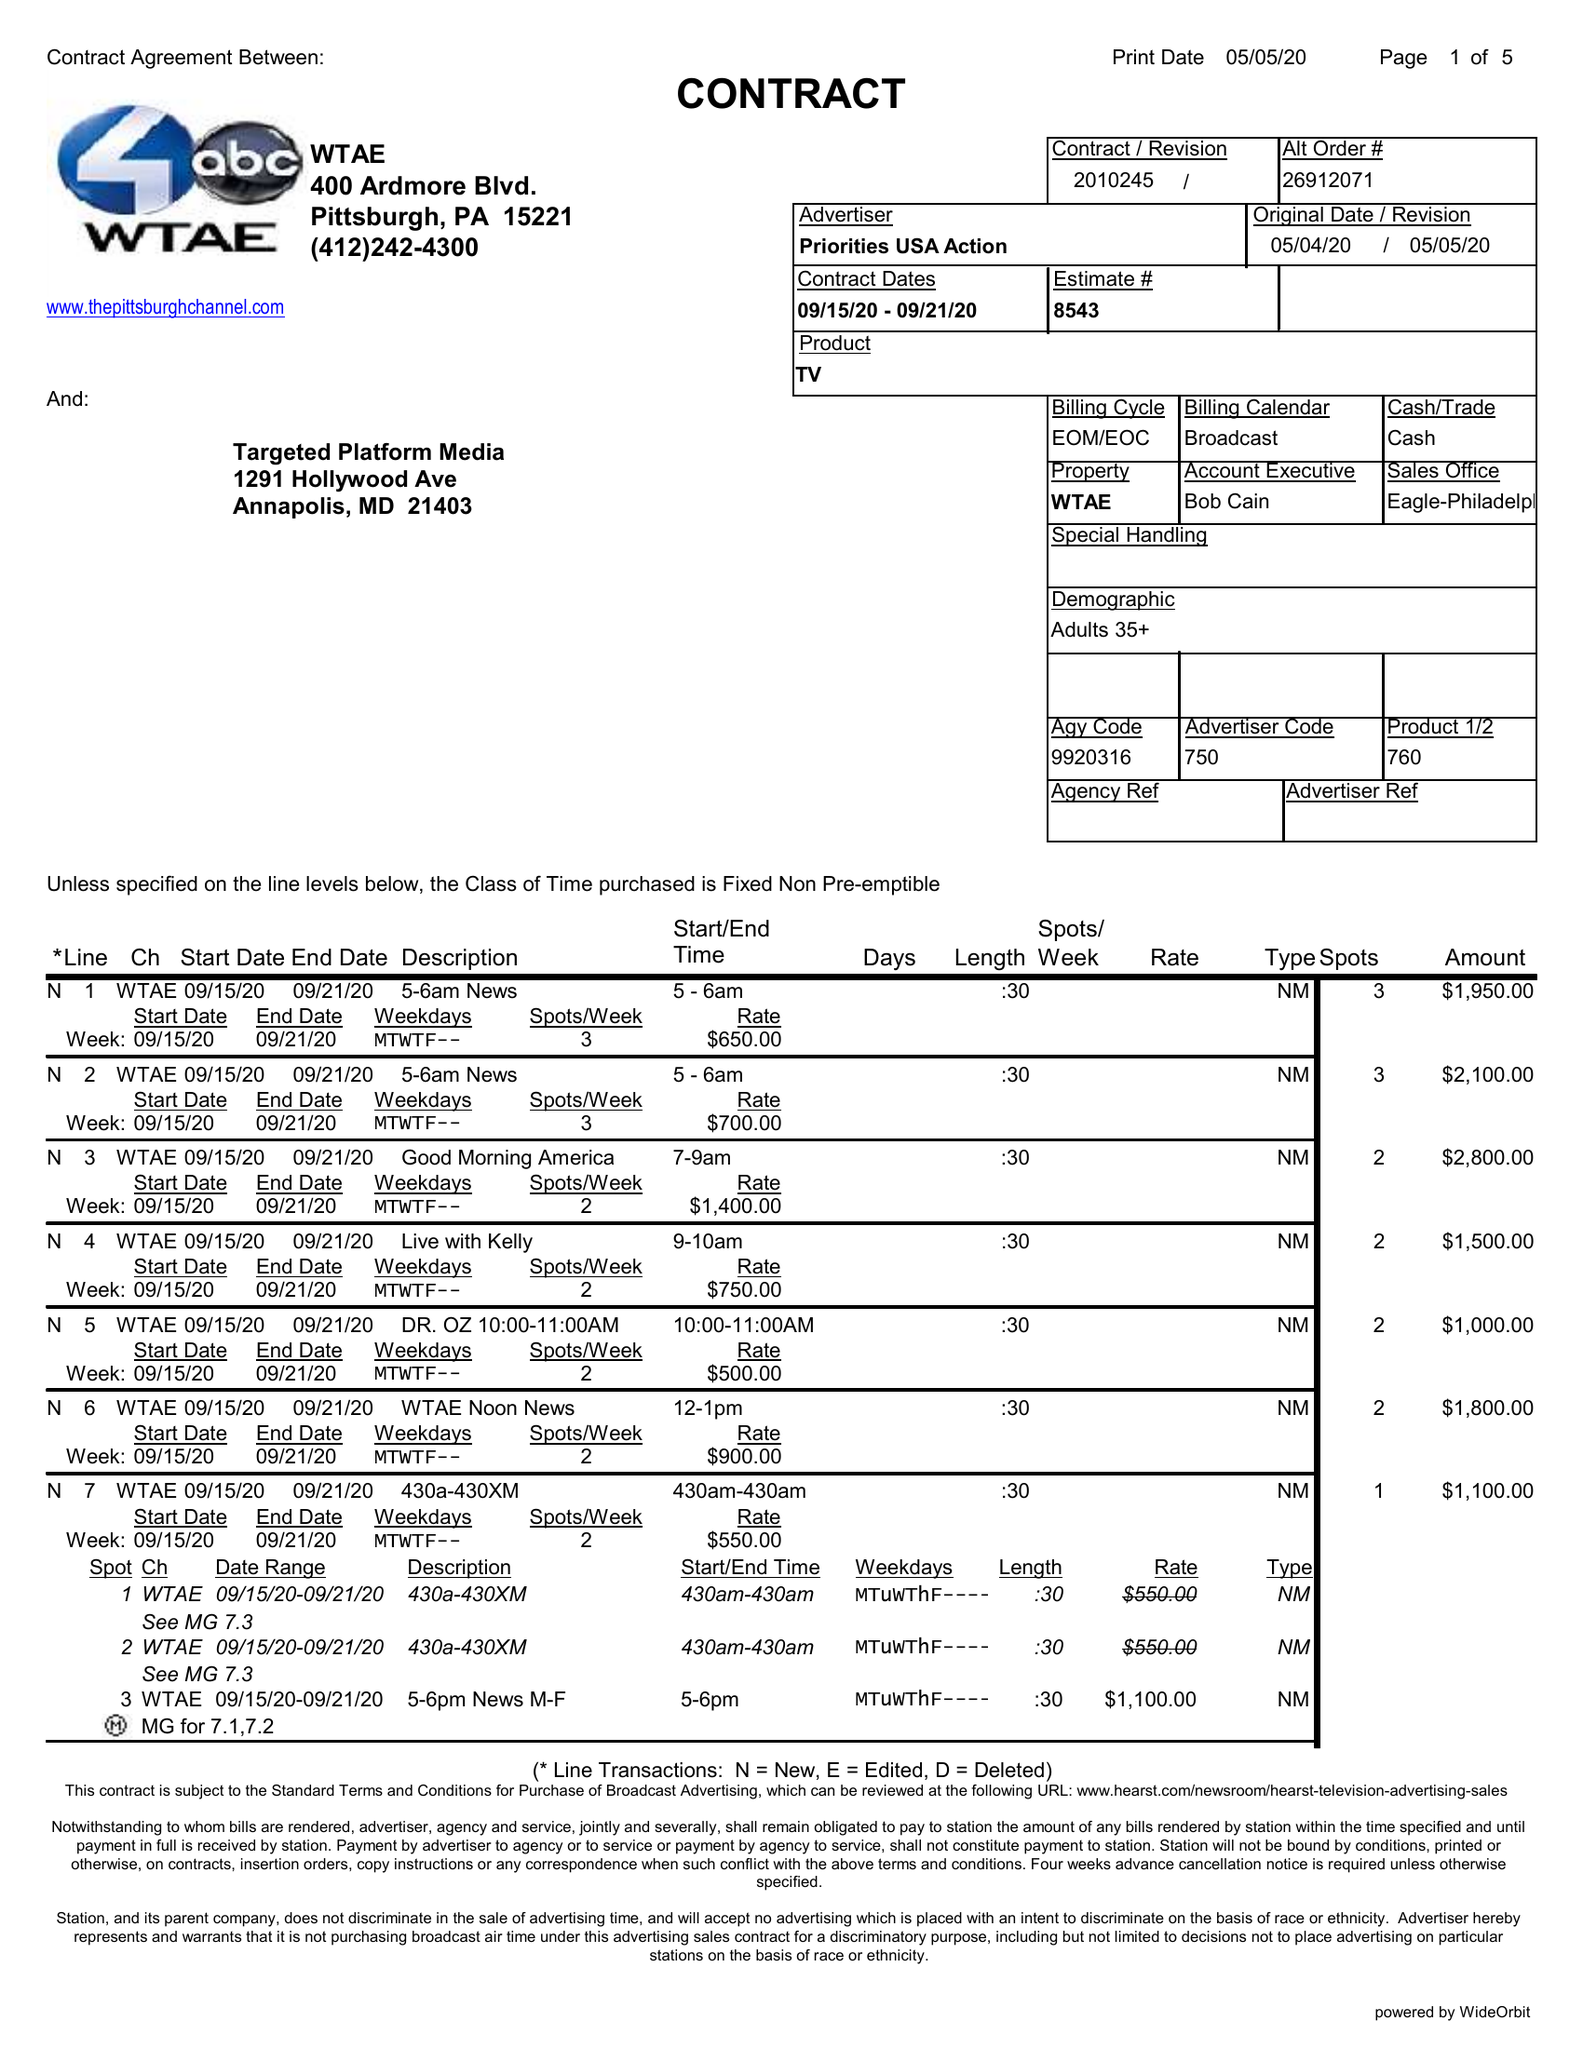What is the value for the flight_from?
Answer the question using a single word or phrase. 09/15/20 